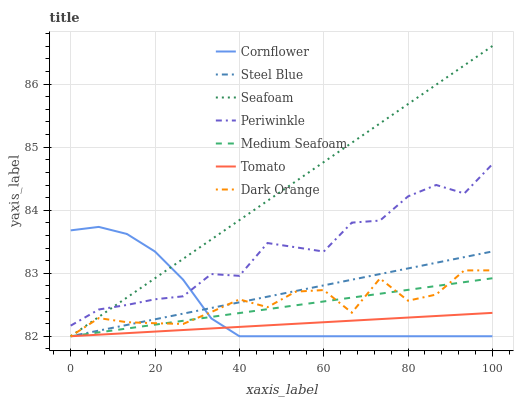Does Tomato have the minimum area under the curve?
Answer yes or no. Yes. Does Seafoam have the maximum area under the curve?
Answer yes or no. Yes. Does Cornflower have the minimum area under the curve?
Answer yes or no. No. Does Cornflower have the maximum area under the curve?
Answer yes or no. No. Is Steel Blue the smoothest?
Answer yes or no. Yes. Is Dark Orange the roughest?
Answer yes or no. Yes. Is Cornflower the smoothest?
Answer yes or no. No. Is Cornflower the roughest?
Answer yes or no. No. Does Tomato have the lowest value?
Answer yes or no. Yes. Does Periwinkle have the lowest value?
Answer yes or no. No. Does Seafoam have the highest value?
Answer yes or no. Yes. Does Cornflower have the highest value?
Answer yes or no. No. Is Dark Orange less than Periwinkle?
Answer yes or no. Yes. Is Periwinkle greater than Dark Orange?
Answer yes or no. Yes. Does Cornflower intersect Periwinkle?
Answer yes or no. Yes. Is Cornflower less than Periwinkle?
Answer yes or no. No. Is Cornflower greater than Periwinkle?
Answer yes or no. No. Does Dark Orange intersect Periwinkle?
Answer yes or no. No. 